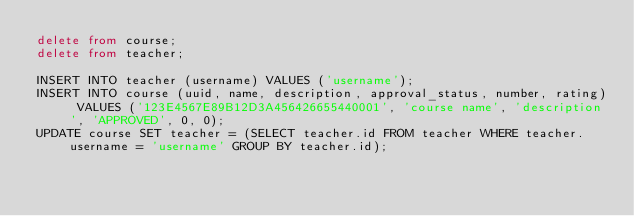<code> <loc_0><loc_0><loc_500><loc_500><_SQL_>delete from course;
delete from teacher;

INSERT INTO teacher (username) VALUES ('username');
INSERT INTO course (uuid, name, description, approval_status, number, rating) VALUES ('123E4567E89B12D3A456426655440001', 'course name', 'description', 'APPROVED', 0, 0);
UPDATE course SET teacher = (SELECT teacher.id FROM teacher WHERE teacher.username = 'username' GROUP BY teacher.id);
</code> 